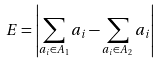Convert formula to latex. <formula><loc_0><loc_0><loc_500><loc_500>E = \left | \sum _ { a _ { i } \in A _ { 1 } } a _ { i } - \sum _ { a _ { i } \in A _ { 2 } } a _ { i } \right |</formula> 